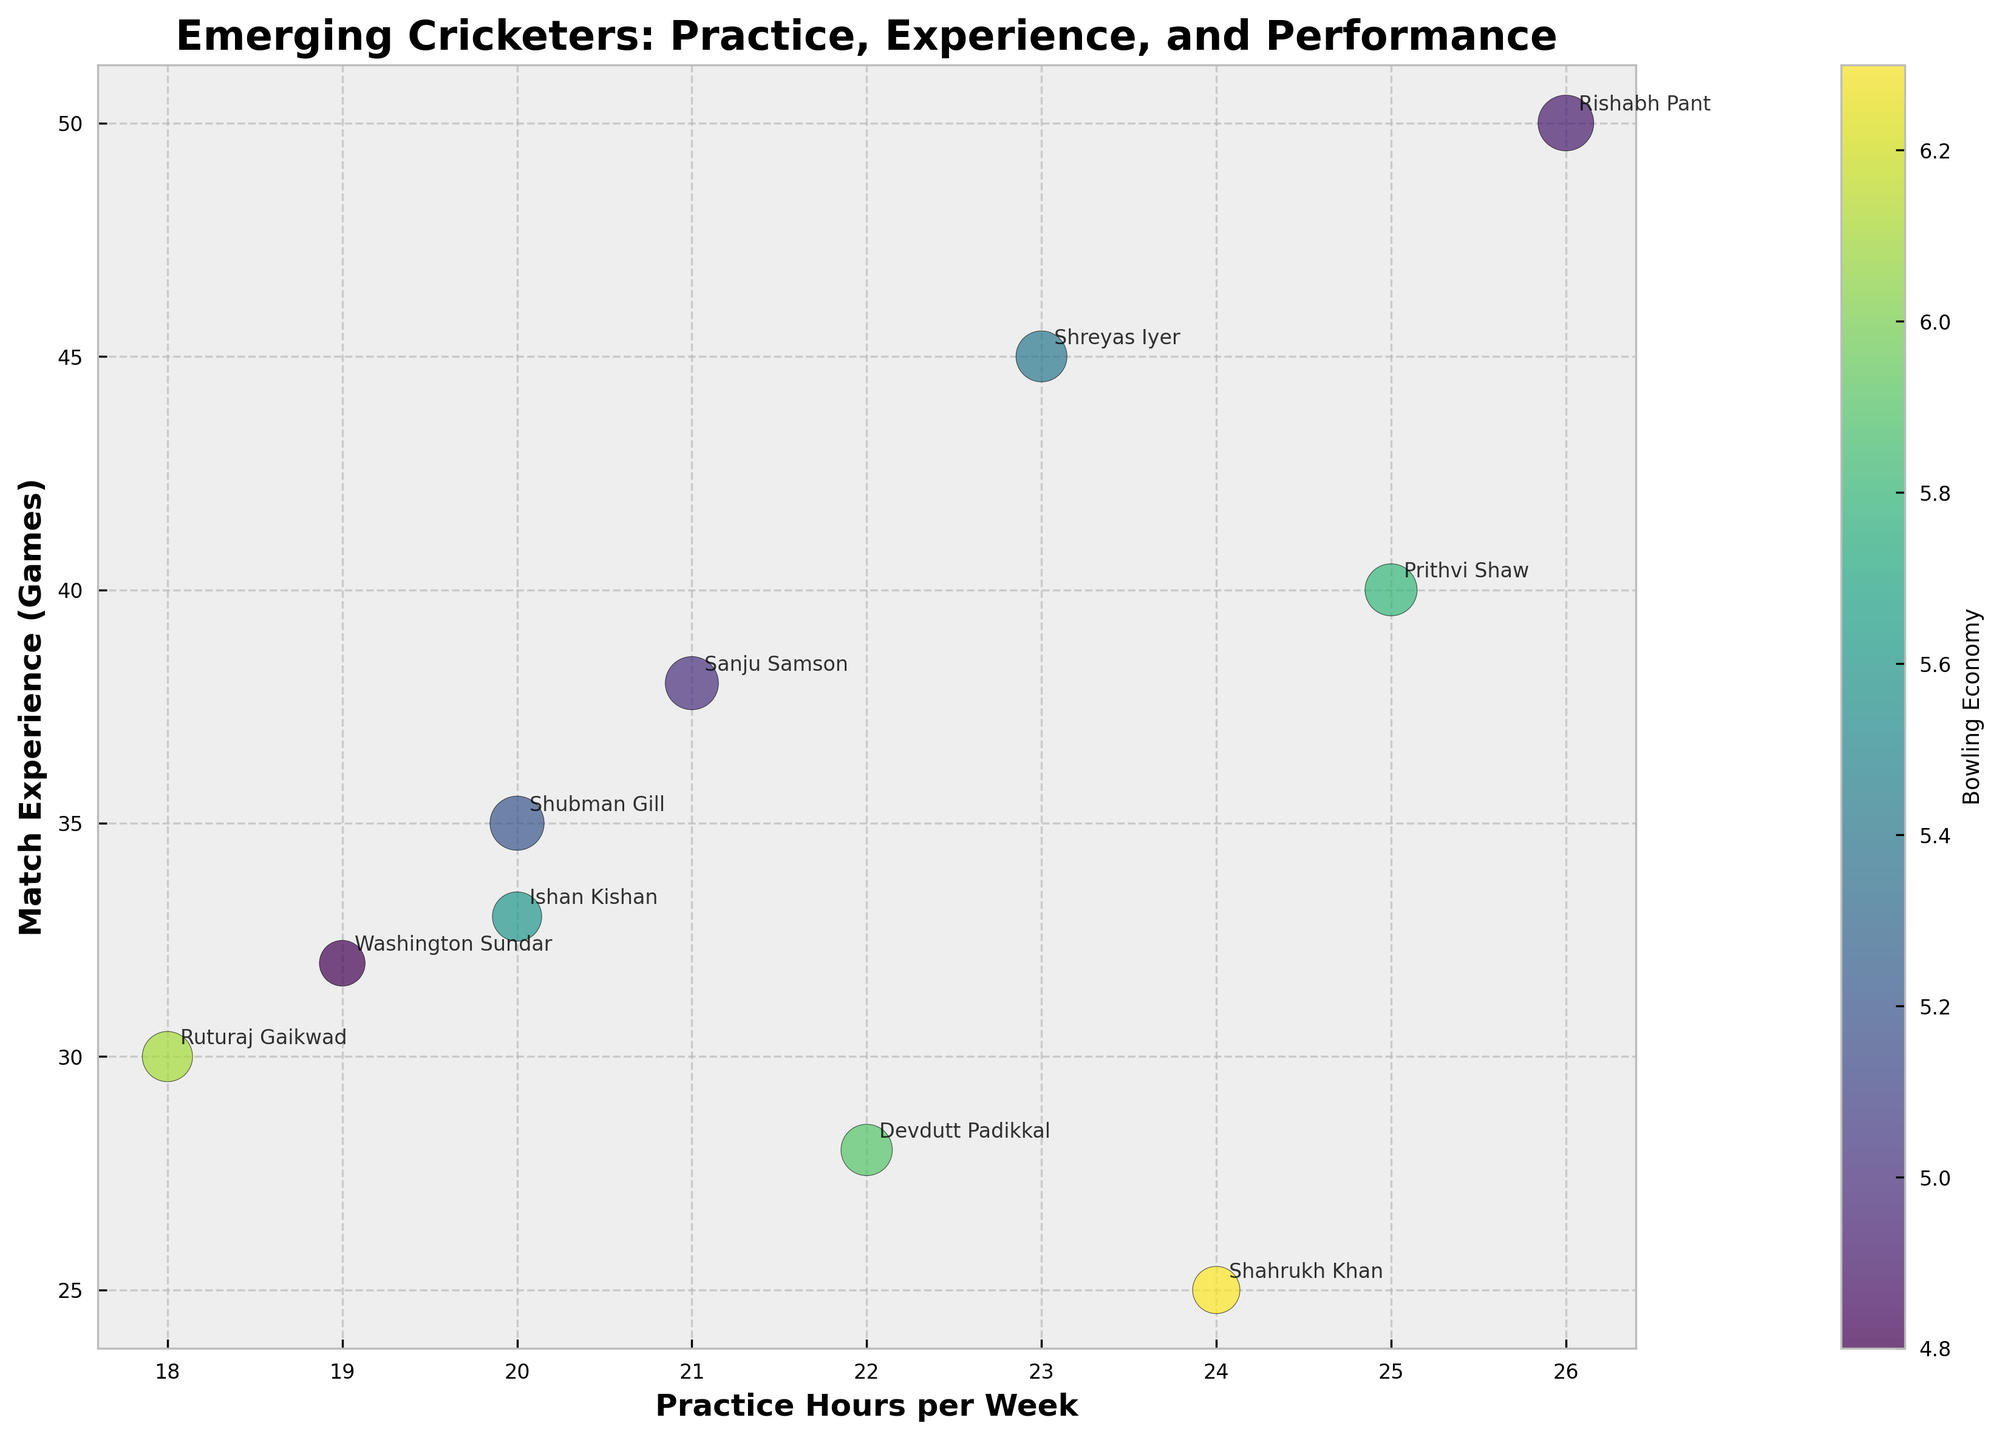How many players have a practice schedule of more than 20 hours per week? The x-axis represents practice hours per week. To answer this question, count the number of points (bubbles) on the chart that are situated to the right of 20 on the x-axis.
Answer: 6 Which player has the highest batting average? The size of each bubble represents the batting average, so the largest bubble indicates the highest batting average.
Answer: Rishabh Pant Among the players who practice 20 hours per week, who has more match experience? Identify the players at the 20-hour mark on the x-axis. Compare their positions on the y-axis, which represents match experience.
Answer: Ishan Kishan What is the color of the data point with the lowest bowling economy? The color of each bubble represents the bowling economy, with a legend provided. The lightest color bubble corresponds to the lowest bowling economy.
Answer: Washington Sundar Who has a better batting average: Prithvi Shaw or Ruturaj Gaikwad? Compare the sizes of the bubbles for Prithvi Shaw and Ruturaj Gaikwad. The larger bubble indicates a higher batting average.
Answer: Prithvi Shaw Which player with more than 35 match experiences has the best bowling economy? Filter the players above 35 on the y-axis. Check the colors for these players; the darkest color represents the best bowling economy.
Answer: Rishabh Pant Is there any player with a batting average higher than 45 and a practice schedule of less than 22 hours a week? Look for the largest bubbles (indicating high batting average) situated to the left of 22 on the x-axis.
Answer: Yes, Shubman Gill and Sanju Samson Which player practicing between 20 and 25 hours per week has the highest match experience? Identify the bubbles with x-values between 20 and 25, then find the highest corresponding value on the y-axis.
Answer: Shreyas Iyer 